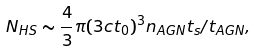Convert formula to latex. <formula><loc_0><loc_0><loc_500><loc_500>N _ { H S } \sim \frac { 4 } { 3 } \pi ( 3 c t _ { 0 } ) ^ { 3 } n _ { A G N } t _ { s } / t _ { A G N } ,</formula> 